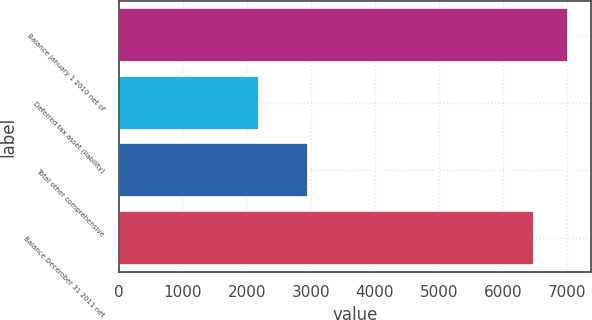Convert chart. <chart><loc_0><loc_0><loc_500><loc_500><bar_chart><fcel>Balance January 1 2010 net of<fcel>Deferred tax asset (liability)<fcel>Total other comprehensive<fcel>Balance December 31 2011 net<nl><fcel>7021<fcel>2186<fcel>2963<fcel>6481<nl></chart> 